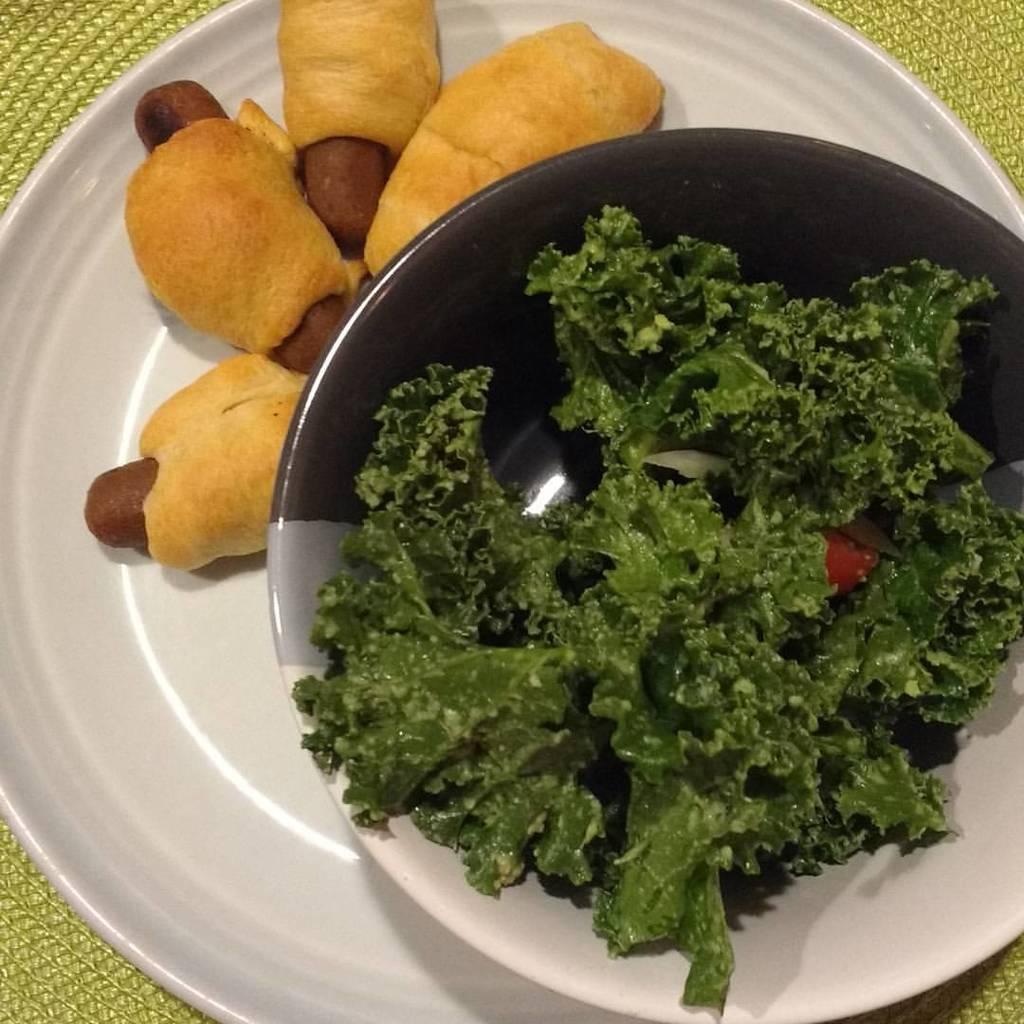In one or two sentences, can you explain what this image depicts? In this picture we plate, food, vegetables and bowl on the platform. 